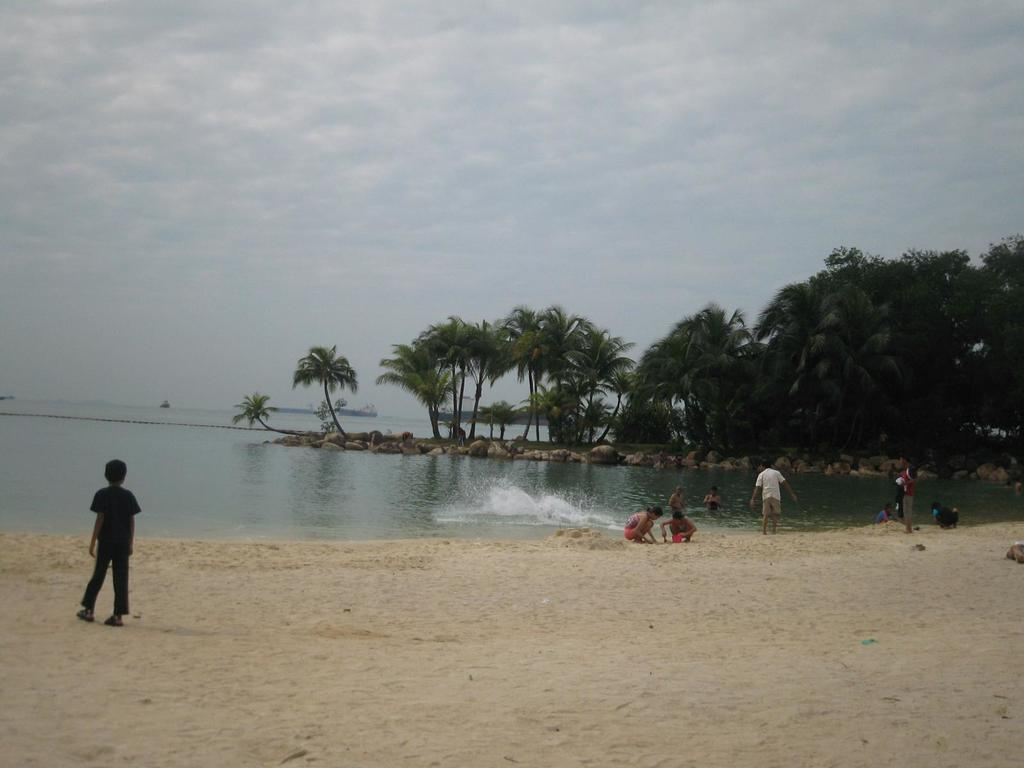What is the primary element in the image? There is water in the image. Are there any living beings present in the image? Yes, there are people in the image. What can be found at the bottom of the image? There is sand at the bottom of the image. What is visible in the background of the image? There are trees and the sky in the background of the image. What type of cart can be seen in the image? There is no cart present in the image. 